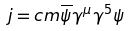Convert formula to latex. <formula><loc_0><loc_0><loc_500><loc_500>j = c m \overline { \psi } \gamma ^ { \mu } \gamma ^ { 5 } \psi</formula> 